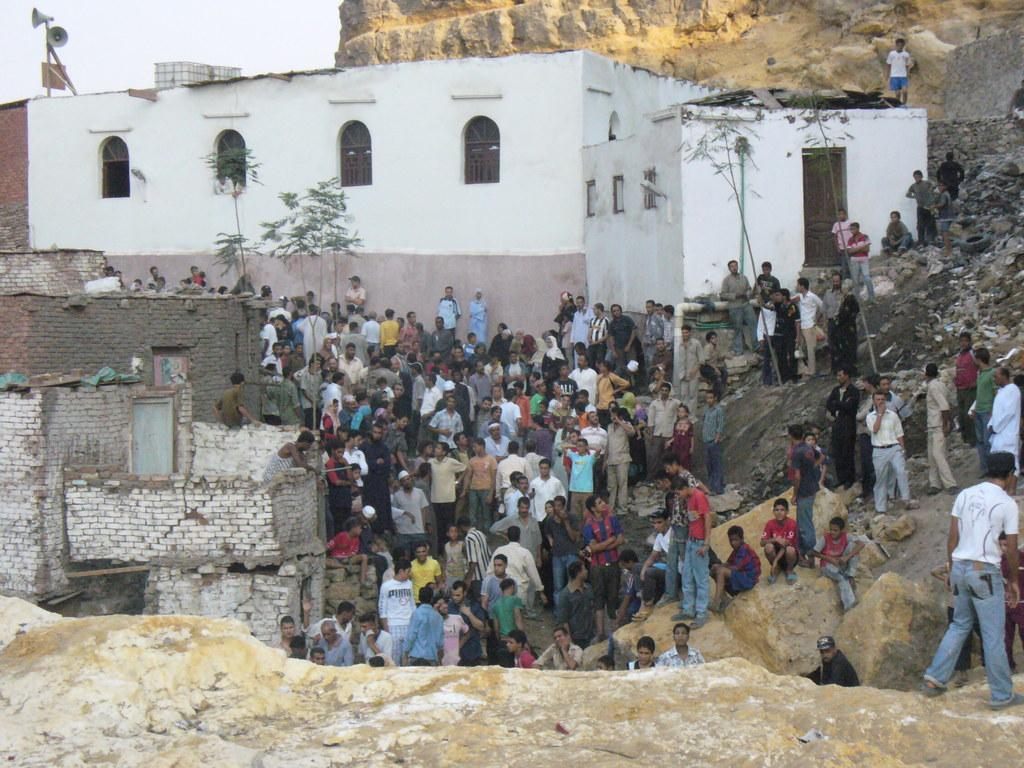How many people are in the image? There are people in the image, but the exact number is not specified. What are some of the people doing in the image? Some people are sitting on rocks in the image. What type of natural elements can be seen in the image? There are trees in the image. What type of structures can be seen in the image? There are houses in the image. What features of the houses are visible in the image? There are windows and lights visible in the image. What type of equipment is present in the image? There are speakers in the image. What is visible in the sky in the image? The sky is visible in the image. What type of quilt is being used to cover the fish in the image? There is no quilt or fish present in the image. How many friends are visible in the image? The facts do not mention friends or their visibility in the image. 